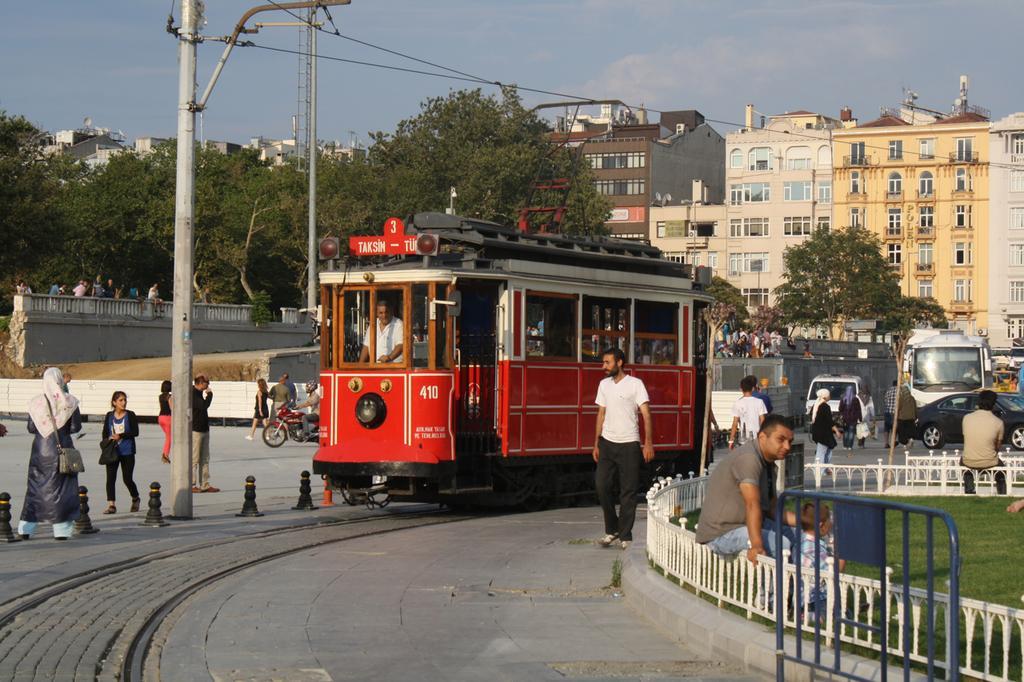In one or two sentences, can you explain what this image depicts? In this image we can see a few people walking on the ground and a few people sitting on the fence. And there are vehicles on the ground and a train. We can see a person inside the train. And there are buildings, wall, trees, current poles and sky in the background. 